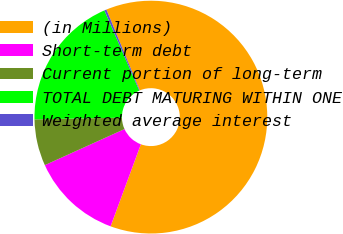Convert chart to OTSL. <chart><loc_0><loc_0><loc_500><loc_500><pie_chart><fcel>(in Millions)<fcel>Short-term debt<fcel>Current portion of long-term<fcel>TOTAL DEBT MATURING WITHIN ONE<fcel>Weighted average interest<nl><fcel>61.87%<fcel>12.61%<fcel>6.46%<fcel>18.77%<fcel>0.3%<nl></chart> 